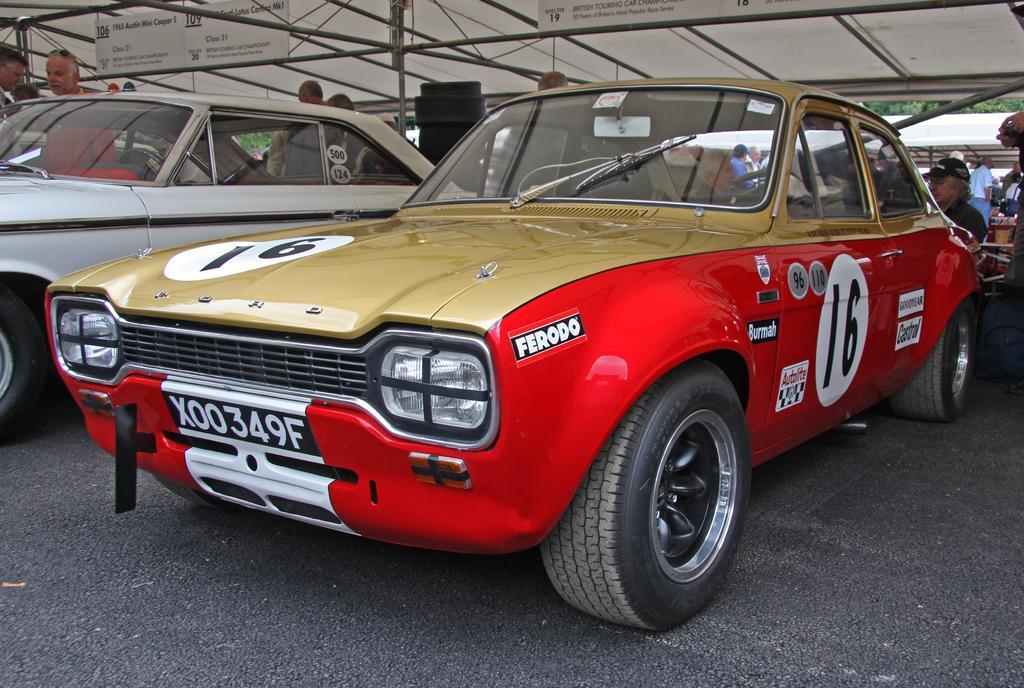Could you give a brief overview of what you see in this image? In this image we can see two cars. One is in white color, the other one is in golden and red color. Behind them people are standing and siting. The cars are under white color shelter. 